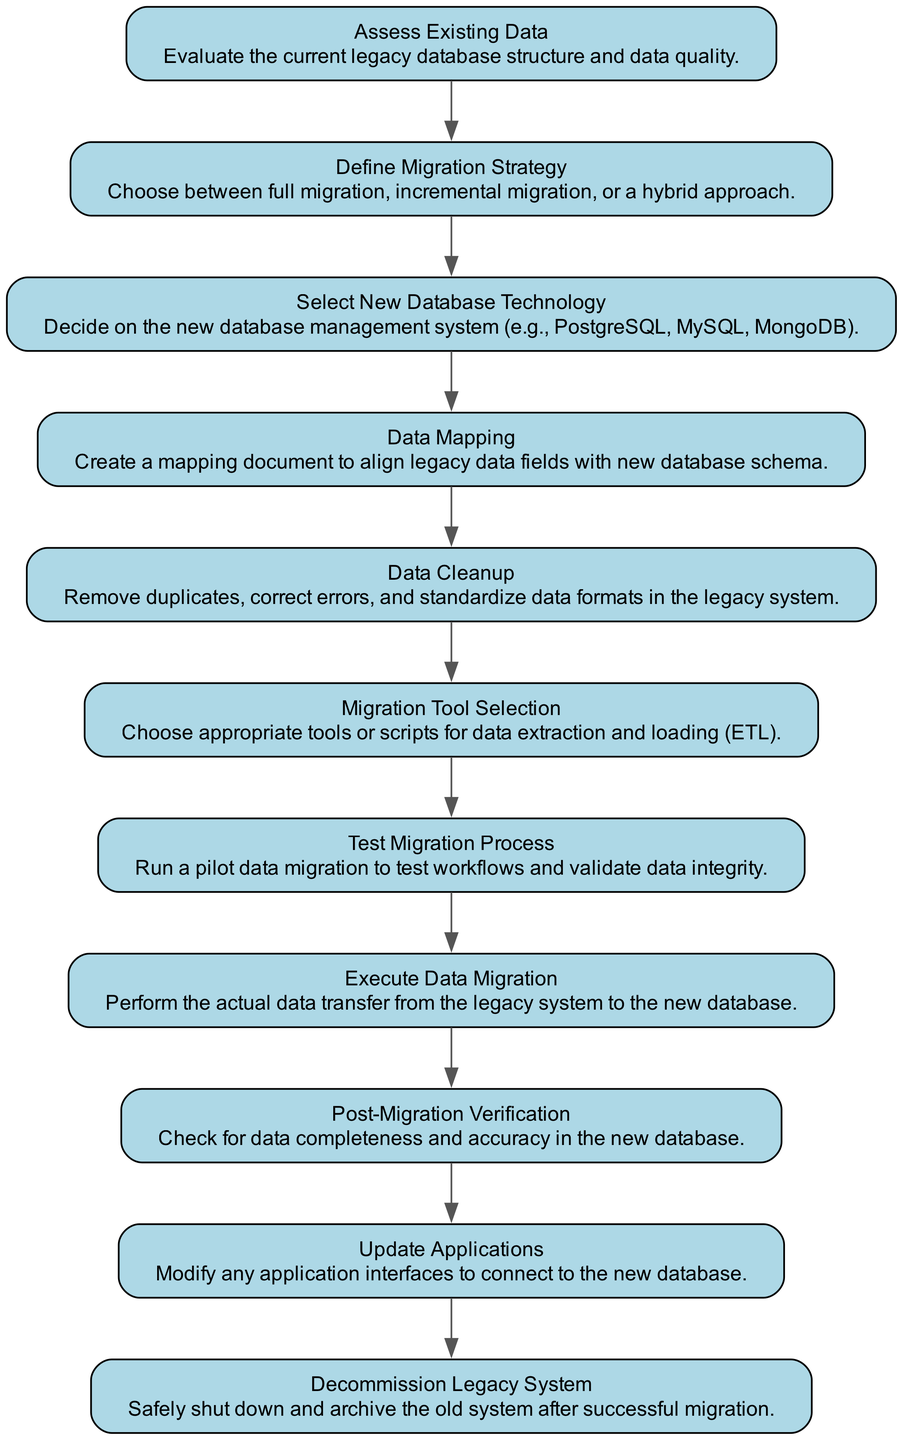What is the first step in the data migration workflow? The first step in the data migration workflow, as indicated in the diagram, is "Assess Existing Data." This is the starting point before moving onto subsequent steps.
Answer: Assess Existing Data How many steps are involved in the data migration workflow? The diagram lists a total of eleven steps in the data migration workflow, starting from the assessment of existing data through to decommissioning the legacy system.
Answer: Eleven Which step comes after "Data Cleanup"? Following the "Data Cleanup" step, the next step depicted in the diagram is "Migration Tool Selection." This indicates that after cleaning up data, the next task is to choose the appropriate tools for migration.
Answer: Migration Tool Selection What kind of verification occurs after executing data migration? The diagram specifies the "Post-Migration Verification" step, which involves checking for data completeness and accuracy in the new database after the migration has been executed.
Answer: Post-Migration Verification Which step involves choosing a database management system? The step designated as "Select New Database Technology" is where the decision is made regarding which database management system to utilize, such as PostgreSQL, MySQL, or MongoDB.
Answer: Select New Database Technology What is the final step in the data migration workflow? The final step, as represented in the last node of the diagram, is "Decommission Legacy System." This involves shutting down and archiving the old system following successful migration to the new database.
Answer: Decommission Legacy System What action precedes "Execute Data Migration"? Prior to "Execute Data Migration," the action performed is "Test Migration Process." This step is critical for validating the migration workflows and ensuring data integrity before the actual transfer occurs.
Answer: Test Migration Process How does the "Define Migration Strategy" step connect to the overall workflow? The "Define Migration Strategy" step serves as a critical decision point where the selection between full, incremental, or hybrid migration approaches influences the subsequent actions in the workflow, demonstrating its pivotal role in the overall migration process.
Answer: It influences subsequent actions 